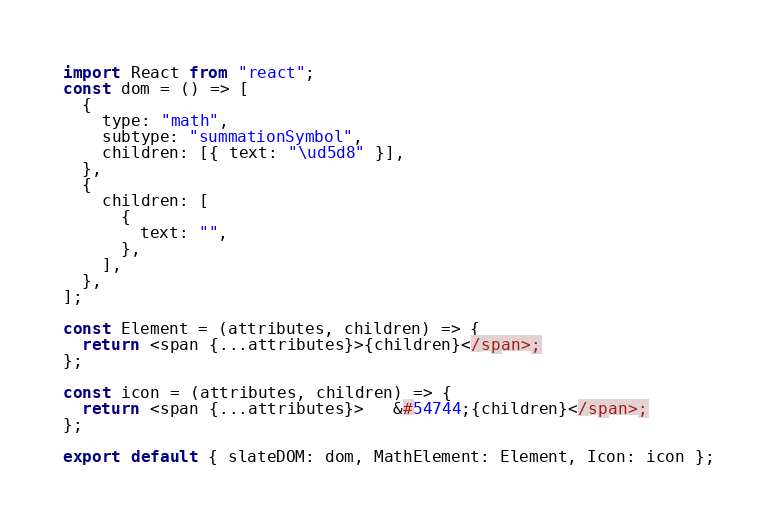Convert code to text. <code><loc_0><loc_0><loc_500><loc_500><_JavaScript_>import React from "react";
const dom = () => [
  {
    type: "math",
    subtype: "summationSymbol",
    children: [{ text: "\ud5d8" }],
  },
  {
    children: [
      {
        text: "",
      },
    ],
  },
];

const Element = (attributes, children) => {
  return <span {...attributes}>{children}</span>;
};

const icon = (attributes, children) => {
  return <span {...attributes}>   &#54744;{children}</span>;
};

export default { slateDOM: dom, MathElement: Element, Icon: icon };</code> 